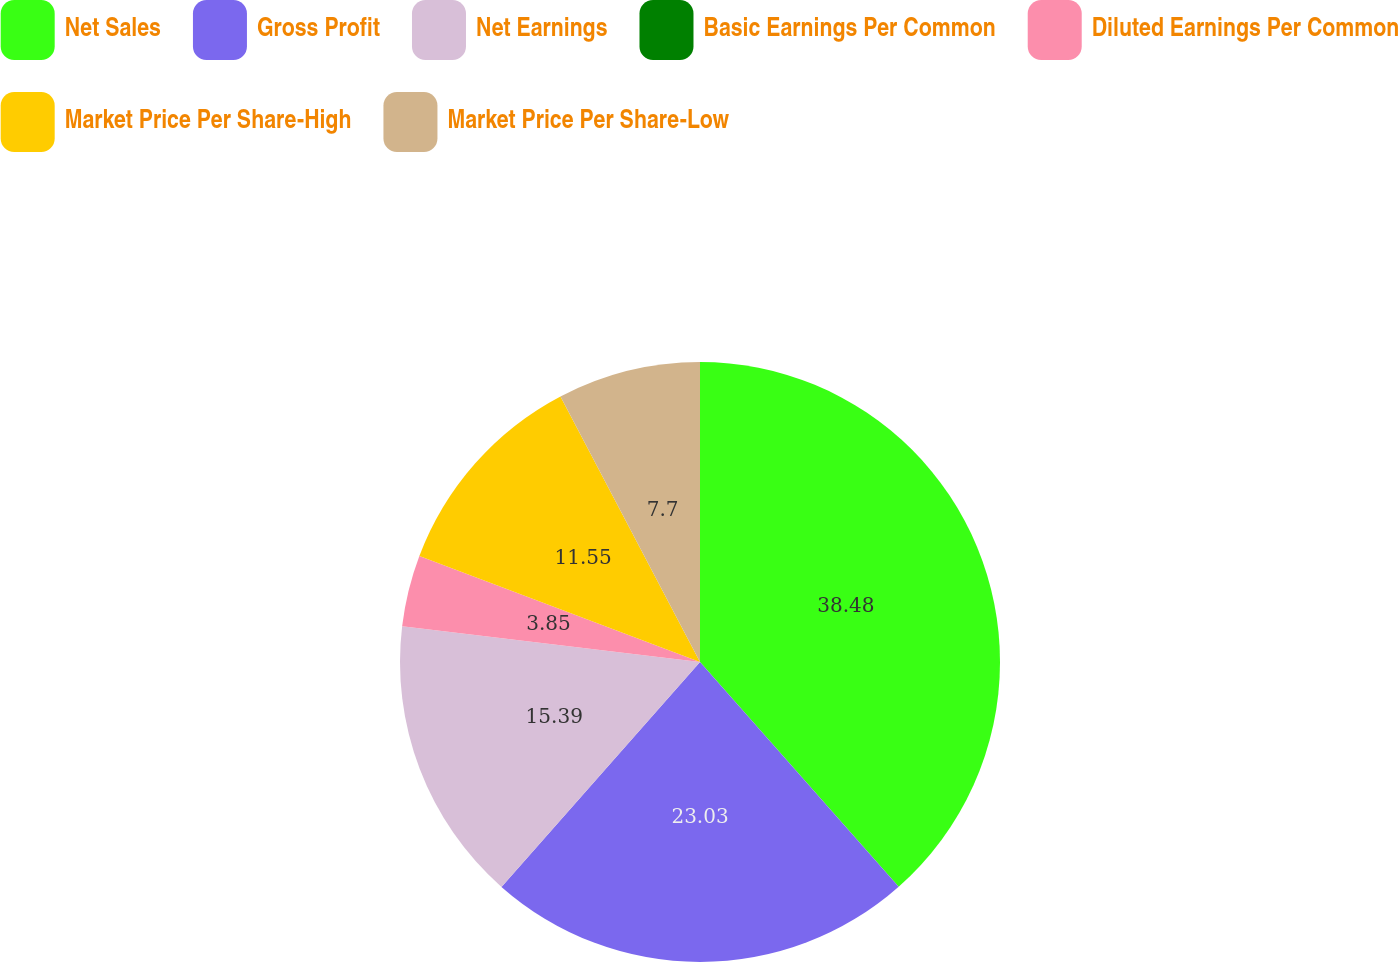Convert chart to OTSL. <chart><loc_0><loc_0><loc_500><loc_500><pie_chart><fcel>Net Sales<fcel>Gross Profit<fcel>Net Earnings<fcel>Basic Earnings Per Common<fcel>Diluted Earnings Per Common<fcel>Market Price Per Share-High<fcel>Market Price Per Share-Low<nl><fcel>38.48%<fcel>23.03%<fcel>15.39%<fcel>0.0%<fcel>3.85%<fcel>11.55%<fcel>7.7%<nl></chart> 